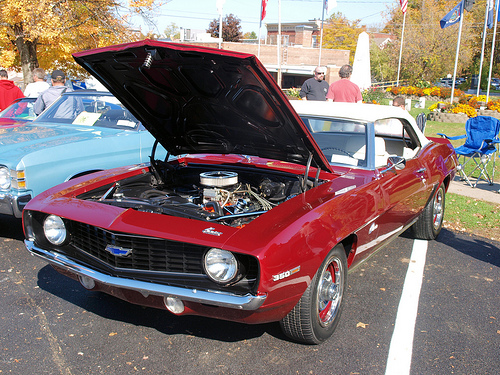<image>
Is there a car in front of the person? Yes. The car is positioned in front of the person, appearing closer to the camera viewpoint. 